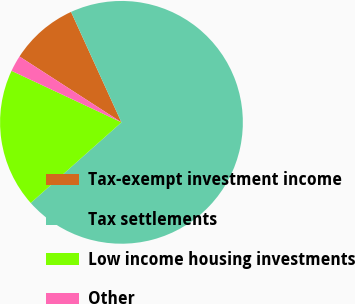Convert chart. <chart><loc_0><loc_0><loc_500><loc_500><pie_chart><fcel>Tax-exempt investment income<fcel>Tax settlements<fcel>Low income housing investments<fcel>Other<nl><fcel>9.06%<fcel>70.26%<fcel>18.54%<fcel>2.15%<nl></chart> 